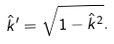<formula> <loc_0><loc_0><loc_500><loc_500>\hat { k } ^ { \prime } = \sqrt { 1 - \hat { k } ^ { 2 } } .</formula> 